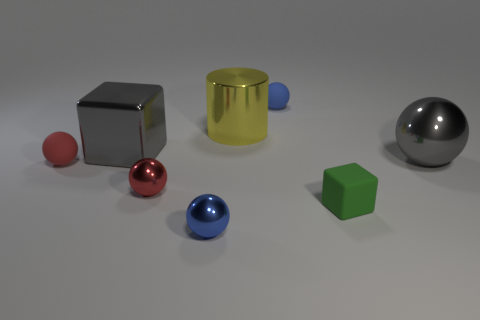Subtract all small red metallic spheres. How many spheres are left? 4 Subtract all gray spheres. How many spheres are left? 4 Subtract all purple spheres. Subtract all yellow blocks. How many spheres are left? 5 Add 1 large red rubber things. How many objects exist? 9 Subtract all cylinders. How many objects are left? 7 Add 3 blue shiny spheres. How many blue shiny spheres are left? 4 Add 6 shiny spheres. How many shiny spheres exist? 9 Subtract 1 gray spheres. How many objects are left? 7 Subtract all gray objects. Subtract all shiny balls. How many objects are left? 3 